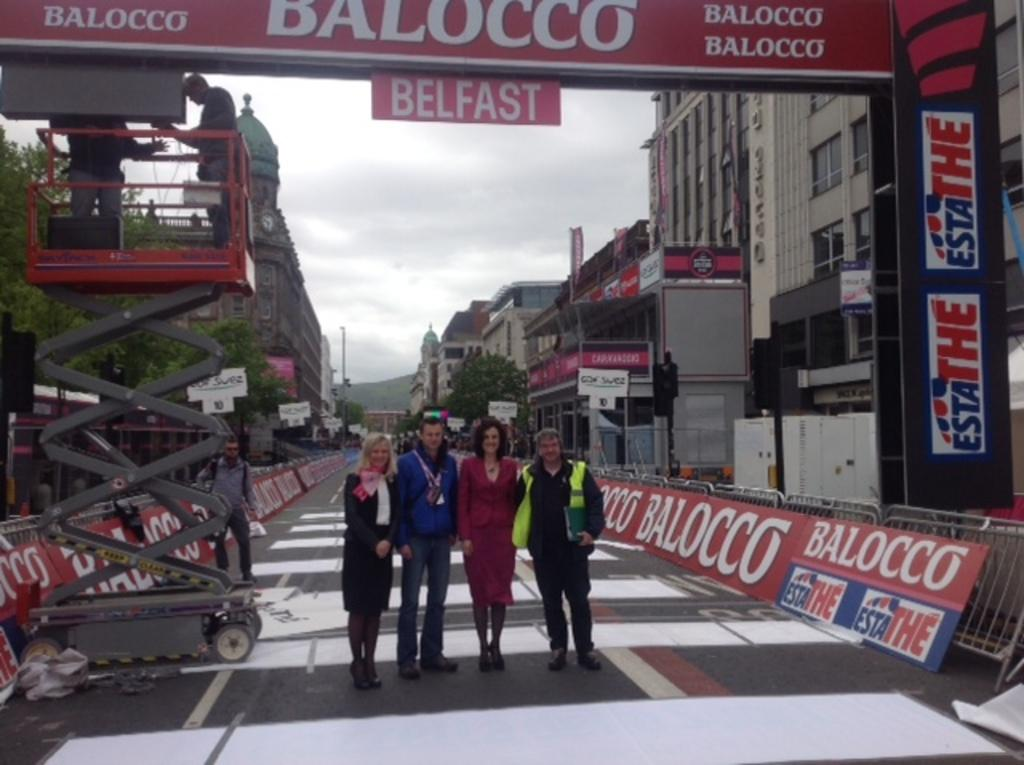What type of decorations are present in the image? There are banners in the image. What type of structures can be seen in the image? There are buildings in the image. What type of natural elements are present in the image? There are trees in the image. What type of gathering or event might be taking place in the image? There is a group of people standing in the image, which suggests a gathering or event. What is visible in the background of the image? The sky is visible in the image. Where is the poison located in the image? There is no poison present in the image. What type of medical facility is depicted in the image? There is no hospital depicted in the image; it features banners, buildings, trees, a group of people, and the sky. What type of container is visible in the image? There is no box present in the image. 